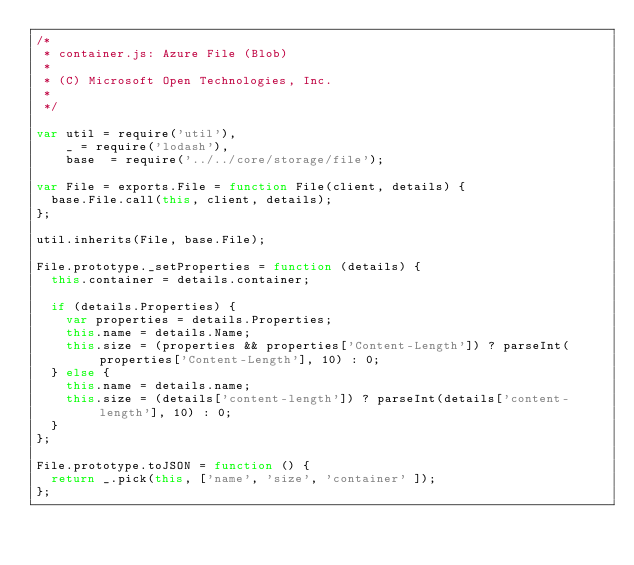<code> <loc_0><loc_0><loc_500><loc_500><_JavaScript_>/*
 * container.js: Azure File (Blob)
 *
 * (C) Microsoft Open Technologies, Inc.
 *
 */

var util = require('util'),
    _ = require('lodash'),
    base  = require('../../core/storage/file');

var File = exports.File = function File(client, details) {
  base.File.call(this, client, details);
};

util.inherits(File, base.File);

File.prototype._setProperties = function (details) {
  this.container = details.container;

  if (details.Properties) {
    var properties = details.Properties;
    this.name = details.Name;
    this.size = (properties && properties['Content-Length']) ? parseInt(properties['Content-Length'], 10) : 0;
  } else {
    this.name = details.name;
    this.size = (details['content-length']) ? parseInt(details['content-length'], 10) : 0;
  }
};

File.prototype.toJSON = function () {
  return _.pick(this, ['name', 'size', 'container' ]);
};</code> 